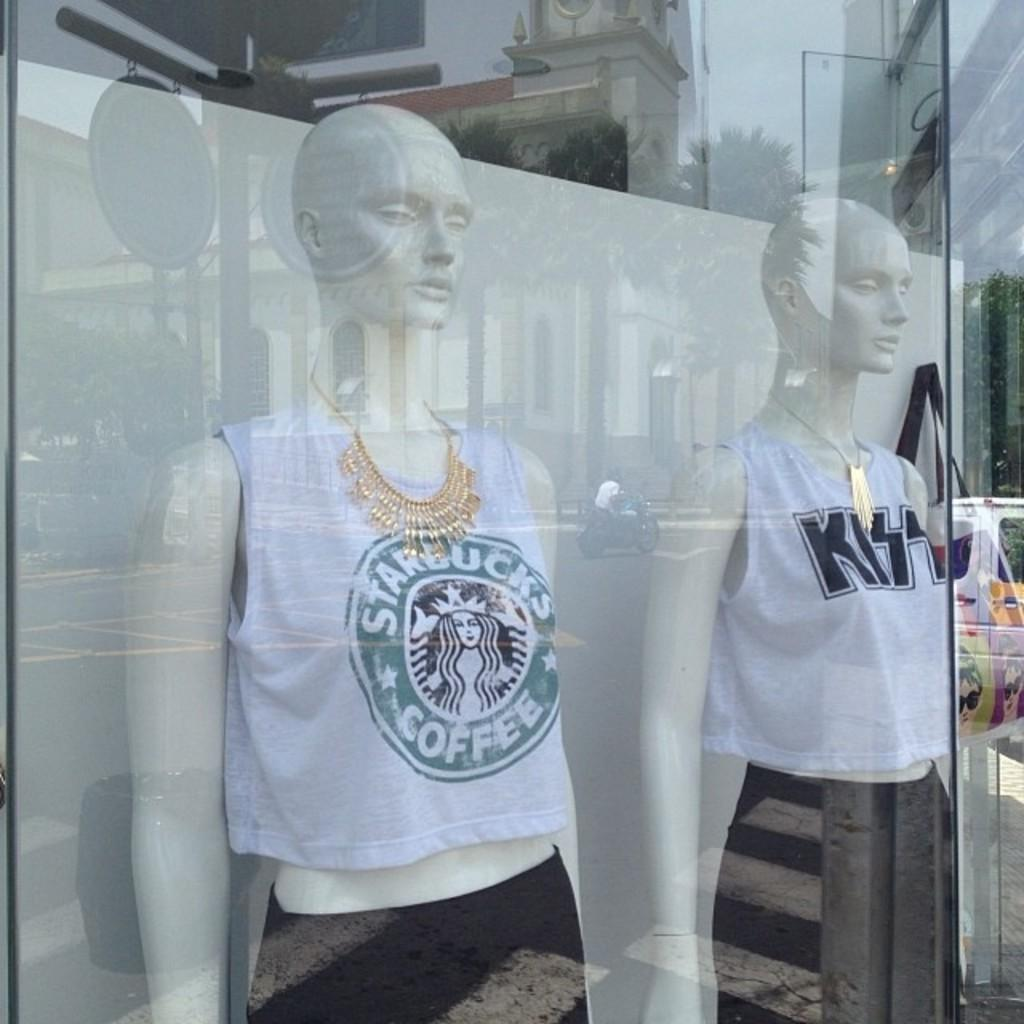<image>
Give a short and clear explanation of the subsequent image. A storefront where mannequins are wearing Starbucks Coffee and KISS tops. 